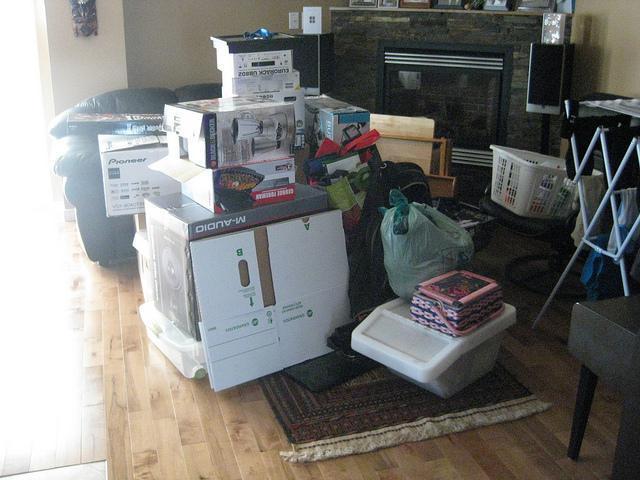How many chairs can be seen?
Give a very brief answer. 2. 